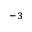<formula> <loc_0><loc_0><loc_500><loc_500>^ { - 3 }</formula> 